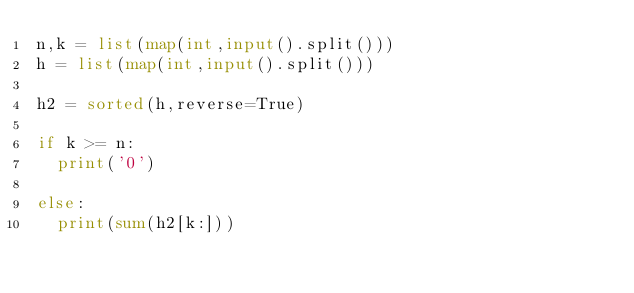<code> <loc_0><loc_0><loc_500><loc_500><_Python_>n,k = list(map(int,input().split()))
h = list(map(int,input().split()))

h2 = sorted(h,reverse=True)

if k >= n:
  print('0')
  
else:
  print(sum(h2[k:]))</code> 